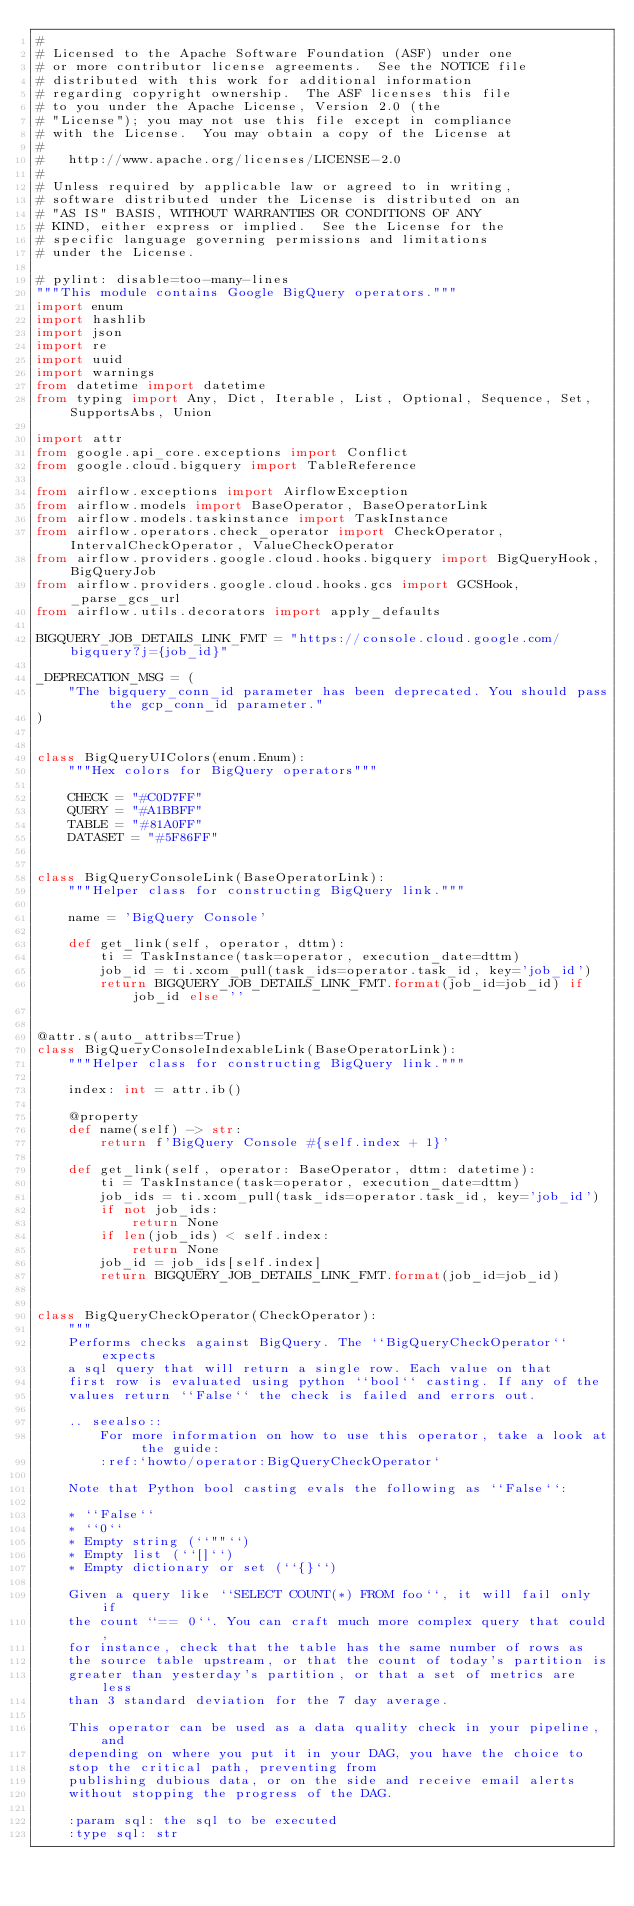Convert code to text. <code><loc_0><loc_0><loc_500><loc_500><_Python_>#
# Licensed to the Apache Software Foundation (ASF) under one
# or more contributor license agreements.  See the NOTICE file
# distributed with this work for additional information
# regarding copyright ownership.  The ASF licenses this file
# to you under the Apache License, Version 2.0 (the
# "License"); you may not use this file except in compliance
# with the License.  You may obtain a copy of the License at
#
#   http://www.apache.org/licenses/LICENSE-2.0
#
# Unless required by applicable law or agreed to in writing,
# software distributed under the License is distributed on an
# "AS IS" BASIS, WITHOUT WARRANTIES OR CONDITIONS OF ANY
# KIND, either express or implied.  See the License for the
# specific language governing permissions and limitations
# under the License.

# pylint: disable=too-many-lines
"""This module contains Google BigQuery operators."""
import enum
import hashlib
import json
import re
import uuid
import warnings
from datetime import datetime
from typing import Any, Dict, Iterable, List, Optional, Sequence, Set, SupportsAbs, Union

import attr
from google.api_core.exceptions import Conflict
from google.cloud.bigquery import TableReference

from airflow.exceptions import AirflowException
from airflow.models import BaseOperator, BaseOperatorLink
from airflow.models.taskinstance import TaskInstance
from airflow.operators.check_operator import CheckOperator, IntervalCheckOperator, ValueCheckOperator
from airflow.providers.google.cloud.hooks.bigquery import BigQueryHook, BigQueryJob
from airflow.providers.google.cloud.hooks.gcs import GCSHook, _parse_gcs_url
from airflow.utils.decorators import apply_defaults

BIGQUERY_JOB_DETAILS_LINK_FMT = "https://console.cloud.google.com/bigquery?j={job_id}"

_DEPRECATION_MSG = (
    "The bigquery_conn_id parameter has been deprecated. You should pass the gcp_conn_id parameter."
)


class BigQueryUIColors(enum.Enum):
    """Hex colors for BigQuery operators"""

    CHECK = "#C0D7FF"
    QUERY = "#A1BBFF"
    TABLE = "#81A0FF"
    DATASET = "#5F86FF"


class BigQueryConsoleLink(BaseOperatorLink):
    """Helper class for constructing BigQuery link."""

    name = 'BigQuery Console'

    def get_link(self, operator, dttm):
        ti = TaskInstance(task=operator, execution_date=dttm)
        job_id = ti.xcom_pull(task_ids=operator.task_id, key='job_id')
        return BIGQUERY_JOB_DETAILS_LINK_FMT.format(job_id=job_id) if job_id else ''


@attr.s(auto_attribs=True)
class BigQueryConsoleIndexableLink(BaseOperatorLink):
    """Helper class for constructing BigQuery link."""

    index: int = attr.ib()

    @property
    def name(self) -> str:
        return f'BigQuery Console #{self.index + 1}'

    def get_link(self, operator: BaseOperator, dttm: datetime):
        ti = TaskInstance(task=operator, execution_date=dttm)
        job_ids = ti.xcom_pull(task_ids=operator.task_id, key='job_id')
        if not job_ids:
            return None
        if len(job_ids) < self.index:
            return None
        job_id = job_ids[self.index]
        return BIGQUERY_JOB_DETAILS_LINK_FMT.format(job_id=job_id)


class BigQueryCheckOperator(CheckOperator):
    """
    Performs checks against BigQuery. The ``BigQueryCheckOperator`` expects
    a sql query that will return a single row. Each value on that
    first row is evaluated using python ``bool`` casting. If any of the
    values return ``False`` the check is failed and errors out.

    .. seealso::
        For more information on how to use this operator, take a look at the guide:
        :ref:`howto/operator:BigQueryCheckOperator`

    Note that Python bool casting evals the following as ``False``:

    * ``False``
    * ``0``
    * Empty string (``""``)
    * Empty list (``[]``)
    * Empty dictionary or set (``{}``)

    Given a query like ``SELECT COUNT(*) FROM foo``, it will fail only if
    the count ``== 0``. You can craft much more complex query that could,
    for instance, check that the table has the same number of rows as
    the source table upstream, or that the count of today's partition is
    greater than yesterday's partition, or that a set of metrics are less
    than 3 standard deviation for the 7 day average.

    This operator can be used as a data quality check in your pipeline, and
    depending on where you put it in your DAG, you have the choice to
    stop the critical path, preventing from
    publishing dubious data, or on the side and receive email alerts
    without stopping the progress of the DAG.

    :param sql: the sql to be executed
    :type sql: str</code> 